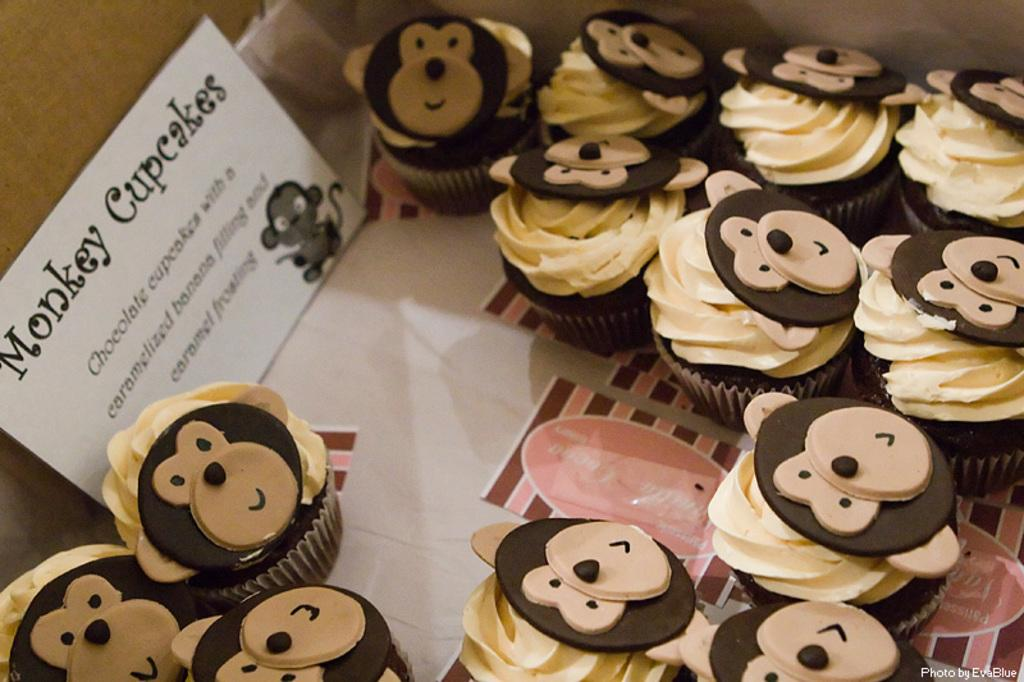What type of food is shown in the image? There are cupcakes in the image. Can you describe any additional features related to the cupcakes? There is a name label beside the cupcakes. Are there any snails crawling on the cupcakes in the image? No, there are no snails present in the image. What is the educational background of the person who made the cupcakes? The provided facts do not mention the educational background of the person who made the cupcakes. 